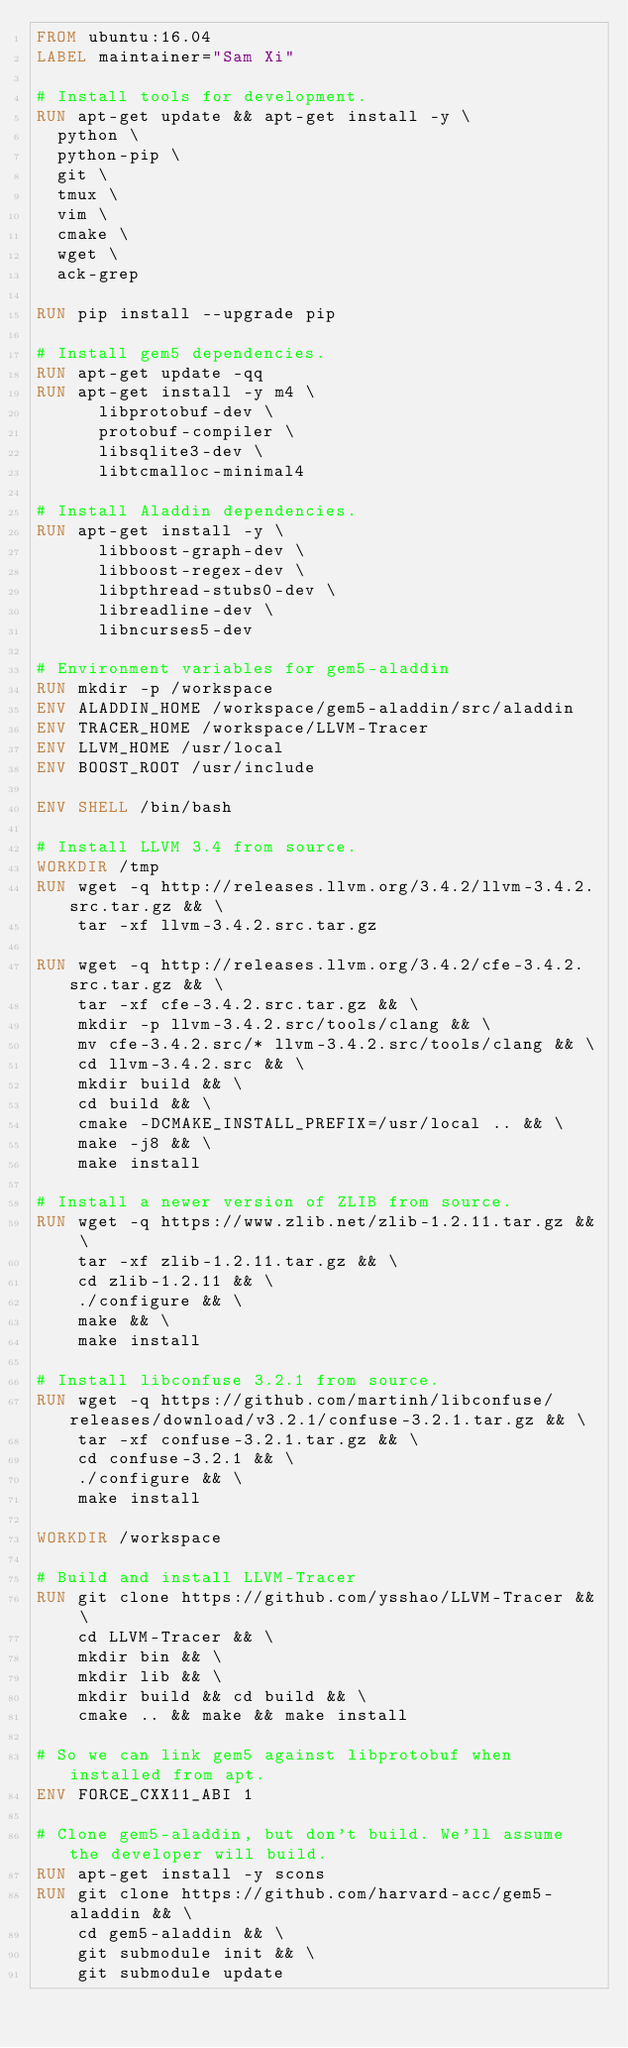<code> <loc_0><loc_0><loc_500><loc_500><_Dockerfile_>FROM ubuntu:16.04
LABEL maintainer="Sam Xi"

# Install tools for development.
RUN apt-get update && apt-get install -y \
  python \
  python-pip \
  git \
  tmux \
  vim \
  cmake \
  wget \
  ack-grep

RUN pip install --upgrade pip

# Install gem5 dependencies.
RUN apt-get update -qq
RUN apt-get install -y m4 \
      libprotobuf-dev \
      protobuf-compiler \
      libsqlite3-dev \
      libtcmalloc-minimal4

# Install Aladdin dependencies.
RUN apt-get install -y \
      libboost-graph-dev \
      libboost-regex-dev \
      libpthread-stubs0-dev \
      libreadline-dev \
      libncurses5-dev

# Environment variables for gem5-aladdin
RUN mkdir -p /workspace
ENV ALADDIN_HOME /workspace/gem5-aladdin/src/aladdin
ENV TRACER_HOME /workspace/LLVM-Tracer
ENV LLVM_HOME /usr/local
ENV BOOST_ROOT /usr/include

ENV SHELL /bin/bash

# Install LLVM 3.4 from source.
WORKDIR /tmp
RUN wget -q http://releases.llvm.org/3.4.2/llvm-3.4.2.src.tar.gz && \
    tar -xf llvm-3.4.2.src.tar.gz

RUN wget -q http://releases.llvm.org/3.4.2/cfe-3.4.2.src.tar.gz && \
    tar -xf cfe-3.4.2.src.tar.gz && \
    mkdir -p llvm-3.4.2.src/tools/clang && \
    mv cfe-3.4.2.src/* llvm-3.4.2.src/tools/clang && \
    cd llvm-3.4.2.src && \
    mkdir build && \
    cd build && \
    cmake -DCMAKE_INSTALL_PREFIX=/usr/local .. && \
    make -j8 && \
    make install

# Install a newer version of ZLIB from source.
RUN wget -q https://www.zlib.net/zlib-1.2.11.tar.gz && \
    tar -xf zlib-1.2.11.tar.gz && \
    cd zlib-1.2.11 && \
    ./configure && \
    make && \
    make install

# Install libconfuse 3.2.1 from source.
RUN wget -q https://github.com/martinh/libconfuse/releases/download/v3.2.1/confuse-3.2.1.tar.gz && \
    tar -xf confuse-3.2.1.tar.gz && \
    cd confuse-3.2.1 && \
    ./configure && \
    make install

WORKDIR /workspace

# Build and install LLVM-Tracer
RUN git clone https://github.com/ysshao/LLVM-Tracer && \
    cd LLVM-Tracer && \
    mkdir bin && \
    mkdir lib && \
    mkdir build && cd build && \
    cmake .. && make && make install

# So we can link gem5 against libprotobuf when installed from apt.
ENV FORCE_CXX11_ABI 1

# Clone gem5-aladdin, but don't build. We'll assume the developer will build.
RUN apt-get install -y scons
RUN git clone https://github.com/harvard-acc/gem5-aladdin && \
    cd gem5-aladdin && \
    git submodule init && \
    git submodule update
</code> 